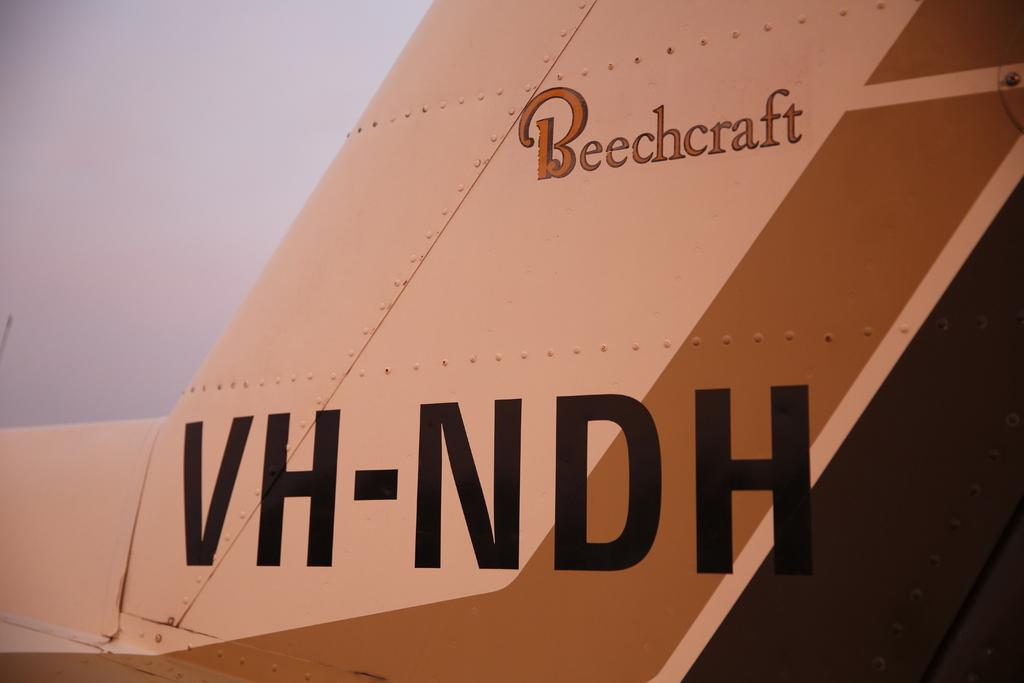<image>
Provide a brief description of the given image. The tail of an airplane with the word Beechcraft 